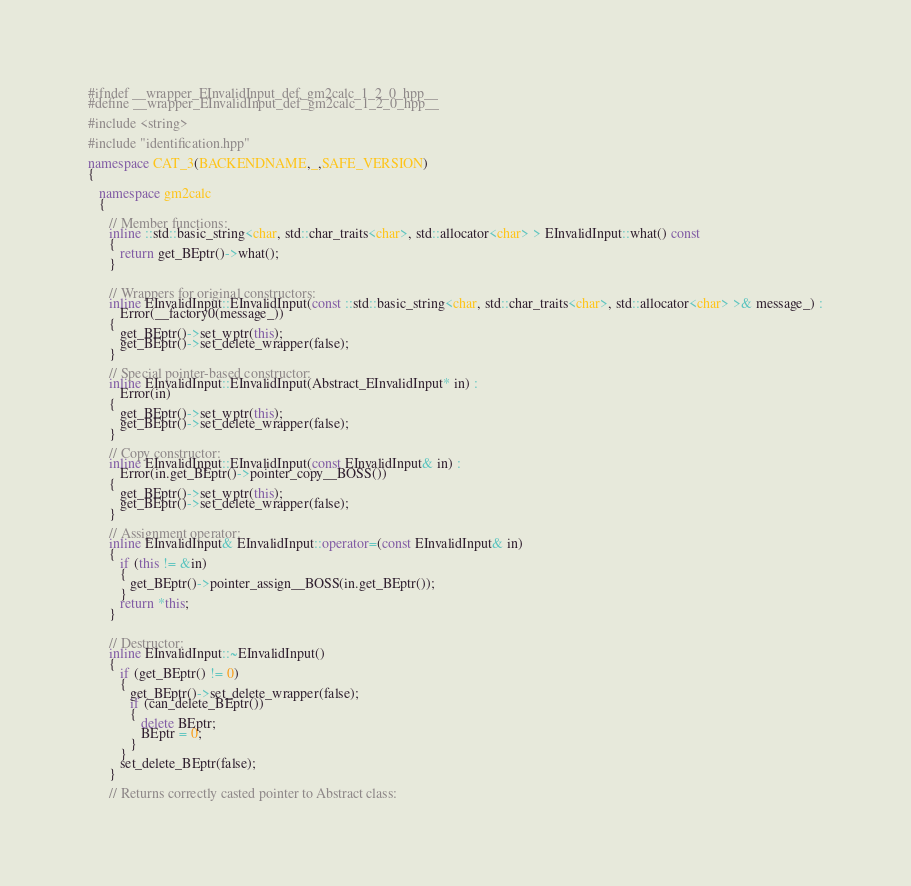<code> <loc_0><loc_0><loc_500><loc_500><_C++_>#ifndef __wrapper_EInvalidInput_def_gm2calc_1_2_0_hpp__
#define __wrapper_EInvalidInput_def_gm2calc_1_2_0_hpp__

#include <string>

#include "identification.hpp"

namespace CAT_3(BACKENDNAME,_,SAFE_VERSION)
{
   
   namespace gm2calc
   {
      
      // Member functions: 
      inline ::std::basic_string<char, std::char_traits<char>, std::allocator<char> > EInvalidInput::what() const
      {
         return get_BEptr()->what();
      }
      
      
      // Wrappers for original constructors: 
      inline EInvalidInput::EInvalidInput(const ::std::basic_string<char, std::char_traits<char>, std::allocator<char> >& message_) :
         Error(__factory0(message_))
      {
         get_BEptr()->set_wptr(this);
         get_BEptr()->set_delete_wrapper(false);
      }
      
      // Special pointer-based constructor: 
      inline EInvalidInput::EInvalidInput(Abstract_EInvalidInput* in) :
         Error(in)
      {
         get_BEptr()->set_wptr(this);
         get_BEptr()->set_delete_wrapper(false);
      }
      
      // Copy constructor: 
      inline EInvalidInput::EInvalidInput(const EInvalidInput& in) :
         Error(in.get_BEptr()->pointer_copy__BOSS())
      {
         get_BEptr()->set_wptr(this);
         get_BEptr()->set_delete_wrapper(false);
      }
      
      // Assignment operator: 
      inline EInvalidInput& EInvalidInput::operator=(const EInvalidInput& in)
      {
         if (this != &in)
         {
            get_BEptr()->pointer_assign__BOSS(in.get_BEptr());
         }
         return *this;
      }
      
      
      // Destructor: 
      inline EInvalidInput::~EInvalidInput()
      {
         if (get_BEptr() != 0)
         {
            get_BEptr()->set_delete_wrapper(false);
            if (can_delete_BEptr())
            {
               delete BEptr;
               BEptr = 0;
            }
         }
         set_delete_BEptr(false);
      }
      
      // Returns correctly casted pointer to Abstract class: </code> 